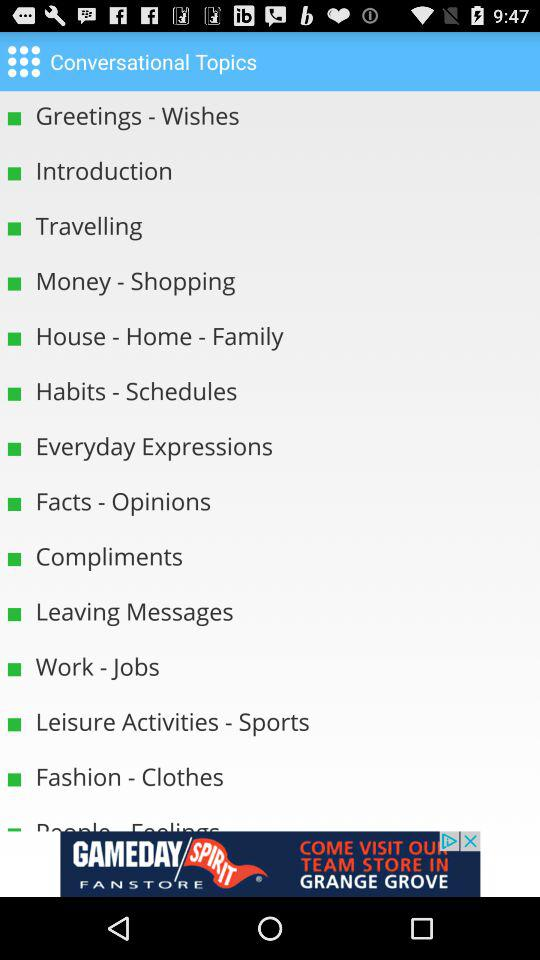What are the names of the topics in house?
When the provided information is insufficient, respond with <no answer>. <no answer> 